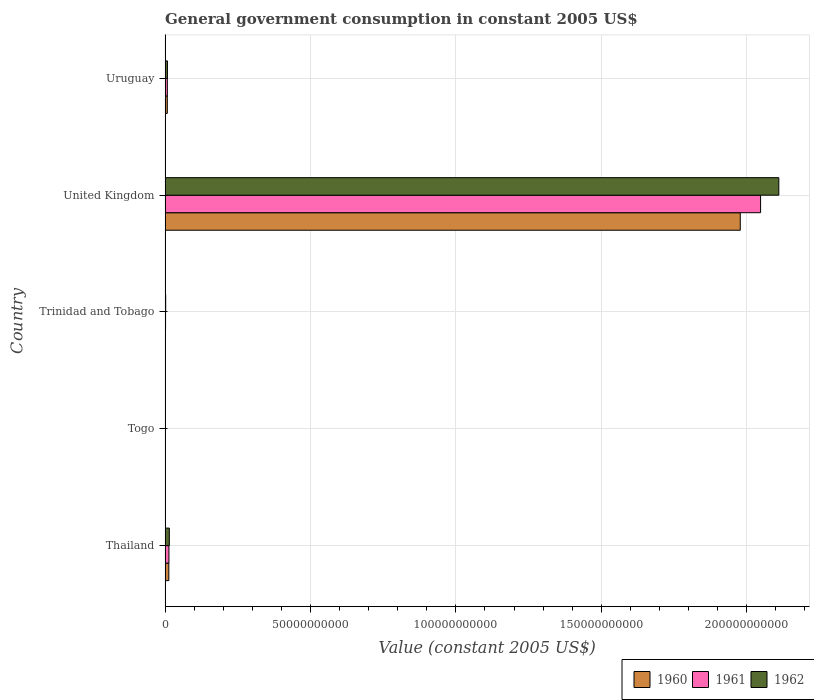How many different coloured bars are there?
Provide a short and direct response. 3. Are the number of bars per tick equal to the number of legend labels?
Give a very brief answer. Yes. Are the number of bars on each tick of the Y-axis equal?
Offer a terse response. Yes. How many bars are there on the 5th tick from the top?
Offer a very short reply. 3. What is the label of the 4th group of bars from the top?
Offer a terse response. Togo. What is the government conusmption in 1962 in Thailand?
Provide a succinct answer. 1.46e+09. Across all countries, what is the maximum government conusmption in 1962?
Your answer should be compact. 2.11e+11. Across all countries, what is the minimum government conusmption in 1961?
Your response must be concise. 4.33e+07. In which country was the government conusmption in 1962 minimum?
Your answer should be compact. Togo. What is the total government conusmption in 1960 in the graph?
Your answer should be very brief. 2.00e+11. What is the difference between the government conusmption in 1960 in Togo and that in Trinidad and Tobago?
Offer a very short reply. -5.67e+07. What is the difference between the government conusmption in 1960 in Togo and the government conusmption in 1961 in Uruguay?
Offer a terse response. -7.26e+08. What is the average government conusmption in 1961 per country?
Your answer should be compact. 4.14e+1. What is the difference between the government conusmption in 1962 and government conusmption in 1961 in United Kingdom?
Your response must be concise. 6.27e+09. What is the ratio of the government conusmption in 1960 in Trinidad and Tobago to that in Uruguay?
Your response must be concise. 0.14. What is the difference between the highest and the second highest government conusmption in 1960?
Give a very brief answer. 1.97e+11. What is the difference between the highest and the lowest government conusmption in 1962?
Offer a terse response. 2.11e+11. What does the 2nd bar from the top in Togo represents?
Offer a very short reply. 1961. What does the 2nd bar from the bottom in Thailand represents?
Provide a short and direct response. 1961. What is the difference between two consecutive major ticks on the X-axis?
Keep it short and to the point. 5.00e+1. Does the graph contain any zero values?
Provide a short and direct response. No. How many legend labels are there?
Make the answer very short. 3. What is the title of the graph?
Provide a succinct answer. General government consumption in constant 2005 US$. What is the label or title of the X-axis?
Your response must be concise. Value (constant 2005 US$). What is the label or title of the Y-axis?
Keep it short and to the point. Country. What is the Value (constant 2005 US$) of 1960 in Thailand?
Your response must be concise. 1.28e+09. What is the Value (constant 2005 US$) of 1961 in Thailand?
Provide a short and direct response. 1.32e+09. What is the Value (constant 2005 US$) of 1962 in Thailand?
Offer a terse response. 1.46e+09. What is the Value (constant 2005 US$) of 1960 in Togo?
Keep it short and to the point. 4.78e+07. What is the Value (constant 2005 US$) of 1961 in Togo?
Your answer should be very brief. 4.33e+07. What is the Value (constant 2005 US$) in 1962 in Togo?
Ensure brevity in your answer.  4.18e+07. What is the Value (constant 2005 US$) in 1960 in Trinidad and Tobago?
Your answer should be compact. 1.05e+08. What is the Value (constant 2005 US$) in 1961 in Trinidad and Tobago?
Your answer should be compact. 1.59e+08. What is the Value (constant 2005 US$) in 1962 in Trinidad and Tobago?
Provide a succinct answer. 2.04e+08. What is the Value (constant 2005 US$) of 1960 in United Kingdom?
Offer a very short reply. 1.98e+11. What is the Value (constant 2005 US$) of 1961 in United Kingdom?
Your answer should be very brief. 2.05e+11. What is the Value (constant 2005 US$) of 1962 in United Kingdom?
Give a very brief answer. 2.11e+11. What is the Value (constant 2005 US$) of 1960 in Uruguay?
Provide a succinct answer. 7.59e+08. What is the Value (constant 2005 US$) of 1961 in Uruguay?
Make the answer very short. 7.74e+08. What is the Value (constant 2005 US$) in 1962 in Uruguay?
Provide a short and direct response. 8.10e+08. Across all countries, what is the maximum Value (constant 2005 US$) of 1960?
Ensure brevity in your answer.  1.98e+11. Across all countries, what is the maximum Value (constant 2005 US$) in 1961?
Your response must be concise. 2.05e+11. Across all countries, what is the maximum Value (constant 2005 US$) in 1962?
Provide a succinct answer. 2.11e+11. Across all countries, what is the minimum Value (constant 2005 US$) of 1960?
Make the answer very short. 4.78e+07. Across all countries, what is the minimum Value (constant 2005 US$) in 1961?
Give a very brief answer. 4.33e+07. Across all countries, what is the minimum Value (constant 2005 US$) in 1962?
Keep it short and to the point. 4.18e+07. What is the total Value (constant 2005 US$) of 1960 in the graph?
Offer a very short reply. 2.00e+11. What is the total Value (constant 2005 US$) of 1961 in the graph?
Your answer should be compact. 2.07e+11. What is the total Value (constant 2005 US$) of 1962 in the graph?
Offer a terse response. 2.14e+11. What is the difference between the Value (constant 2005 US$) of 1960 in Thailand and that in Togo?
Provide a succinct answer. 1.23e+09. What is the difference between the Value (constant 2005 US$) of 1961 in Thailand and that in Togo?
Offer a terse response. 1.28e+09. What is the difference between the Value (constant 2005 US$) of 1962 in Thailand and that in Togo?
Keep it short and to the point. 1.41e+09. What is the difference between the Value (constant 2005 US$) in 1960 in Thailand and that in Trinidad and Tobago?
Offer a very short reply. 1.18e+09. What is the difference between the Value (constant 2005 US$) of 1961 in Thailand and that in Trinidad and Tobago?
Keep it short and to the point. 1.16e+09. What is the difference between the Value (constant 2005 US$) of 1962 in Thailand and that in Trinidad and Tobago?
Offer a very short reply. 1.25e+09. What is the difference between the Value (constant 2005 US$) of 1960 in Thailand and that in United Kingdom?
Give a very brief answer. -1.97e+11. What is the difference between the Value (constant 2005 US$) of 1961 in Thailand and that in United Kingdom?
Offer a very short reply. -2.03e+11. What is the difference between the Value (constant 2005 US$) of 1962 in Thailand and that in United Kingdom?
Provide a short and direct response. -2.10e+11. What is the difference between the Value (constant 2005 US$) of 1960 in Thailand and that in Uruguay?
Your answer should be very brief. 5.21e+08. What is the difference between the Value (constant 2005 US$) of 1961 in Thailand and that in Uruguay?
Your response must be concise. 5.46e+08. What is the difference between the Value (constant 2005 US$) of 1962 in Thailand and that in Uruguay?
Keep it short and to the point. 6.45e+08. What is the difference between the Value (constant 2005 US$) of 1960 in Togo and that in Trinidad and Tobago?
Keep it short and to the point. -5.67e+07. What is the difference between the Value (constant 2005 US$) in 1961 in Togo and that in Trinidad and Tobago?
Give a very brief answer. -1.16e+08. What is the difference between the Value (constant 2005 US$) in 1962 in Togo and that in Trinidad and Tobago?
Provide a short and direct response. -1.62e+08. What is the difference between the Value (constant 2005 US$) in 1960 in Togo and that in United Kingdom?
Your answer should be very brief. -1.98e+11. What is the difference between the Value (constant 2005 US$) in 1961 in Togo and that in United Kingdom?
Keep it short and to the point. -2.05e+11. What is the difference between the Value (constant 2005 US$) of 1962 in Togo and that in United Kingdom?
Give a very brief answer. -2.11e+11. What is the difference between the Value (constant 2005 US$) of 1960 in Togo and that in Uruguay?
Provide a succinct answer. -7.12e+08. What is the difference between the Value (constant 2005 US$) in 1961 in Togo and that in Uruguay?
Provide a succinct answer. -7.30e+08. What is the difference between the Value (constant 2005 US$) in 1962 in Togo and that in Uruguay?
Offer a terse response. -7.68e+08. What is the difference between the Value (constant 2005 US$) of 1960 in Trinidad and Tobago and that in United Kingdom?
Give a very brief answer. -1.98e+11. What is the difference between the Value (constant 2005 US$) in 1961 in Trinidad and Tobago and that in United Kingdom?
Make the answer very short. -2.05e+11. What is the difference between the Value (constant 2005 US$) of 1962 in Trinidad and Tobago and that in United Kingdom?
Offer a very short reply. -2.11e+11. What is the difference between the Value (constant 2005 US$) in 1960 in Trinidad and Tobago and that in Uruguay?
Your answer should be compact. -6.55e+08. What is the difference between the Value (constant 2005 US$) of 1961 in Trinidad and Tobago and that in Uruguay?
Keep it short and to the point. -6.14e+08. What is the difference between the Value (constant 2005 US$) in 1962 in Trinidad and Tobago and that in Uruguay?
Ensure brevity in your answer.  -6.06e+08. What is the difference between the Value (constant 2005 US$) of 1960 in United Kingdom and that in Uruguay?
Your answer should be compact. 1.97e+11. What is the difference between the Value (constant 2005 US$) of 1961 in United Kingdom and that in Uruguay?
Your answer should be very brief. 2.04e+11. What is the difference between the Value (constant 2005 US$) in 1962 in United Kingdom and that in Uruguay?
Keep it short and to the point. 2.10e+11. What is the difference between the Value (constant 2005 US$) in 1960 in Thailand and the Value (constant 2005 US$) in 1961 in Togo?
Ensure brevity in your answer.  1.24e+09. What is the difference between the Value (constant 2005 US$) of 1960 in Thailand and the Value (constant 2005 US$) of 1962 in Togo?
Your response must be concise. 1.24e+09. What is the difference between the Value (constant 2005 US$) in 1961 in Thailand and the Value (constant 2005 US$) in 1962 in Togo?
Give a very brief answer. 1.28e+09. What is the difference between the Value (constant 2005 US$) of 1960 in Thailand and the Value (constant 2005 US$) of 1961 in Trinidad and Tobago?
Give a very brief answer. 1.12e+09. What is the difference between the Value (constant 2005 US$) in 1960 in Thailand and the Value (constant 2005 US$) in 1962 in Trinidad and Tobago?
Your answer should be very brief. 1.08e+09. What is the difference between the Value (constant 2005 US$) of 1961 in Thailand and the Value (constant 2005 US$) of 1962 in Trinidad and Tobago?
Ensure brevity in your answer.  1.12e+09. What is the difference between the Value (constant 2005 US$) of 1960 in Thailand and the Value (constant 2005 US$) of 1961 in United Kingdom?
Keep it short and to the point. -2.04e+11. What is the difference between the Value (constant 2005 US$) in 1960 in Thailand and the Value (constant 2005 US$) in 1962 in United Kingdom?
Keep it short and to the point. -2.10e+11. What is the difference between the Value (constant 2005 US$) in 1961 in Thailand and the Value (constant 2005 US$) in 1962 in United Kingdom?
Ensure brevity in your answer.  -2.10e+11. What is the difference between the Value (constant 2005 US$) of 1960 in Thailand and the Value (constant 2005 US$) of 1961 in Uruguay?
Give a very brief answer. 5.07e+08. What is the difference between the Value (constant 2005 US$) in 1960 in Thailand and the Value (constant 2005 US$) in 1962 in Uruguay?
Give a very brief answer. 4.71e+08. What is the difference between the Value (constant 2005 US$) of 1961 in Thailand and the Value (constant 2005 US$) of 1962 in Uruguay?
Your answer should be very brief. 5.10e+08. What is the difference between the Value (constant 2005 US$) in 1960 in Togo and the Value (constant 2005 US$) in 1961 in Trinidad and Tobago?
Provide a short and direct response. -1.12e+08. What is the difference between the Value (constant 2005 US$) of 1960 in Togo and the Value (constant 2005 US$) of 1962 in Trinidad and Tobago?
Offer a terse response. -1.56e+08. What is the difference between the Value (constant 2005 US$) in 1961 in Togo and the Value (constant 2005 US$) in 1962 in Trinidad and Tobago?
Provide a short and direct response. -1.61e+08. What is the difference between the Value (constant 2005 US$) in 1960 in Togo and the Value (constant 2005 US$) in 1961 in United Kingdom?
Provide a succinct answer. -2.05e+11. What is the difference between the Value (constant 2005 US$) of 1960 in Togo and the Value (constant 2005 US$) of 1962 in United Kingdom?
Provide a succinct answer. -2.11e+11. What is the difference between the Value (constant 2005 US$) in 1961 in Togo and the Value (constant 2005 US$) in 1962 in United Kingdom?
Give a very brief answer. -2.11e+11. What is the difference between the Value (constant 2005 US$) in 1960 in Togo and the Value (constant 2005 US$) in 1961 in Uruguay?
Offer a very short reply. -7.26e+08. What is the difference between the Value (constant 2005 US$) of 1960 in Togo and the Value (constant 2005 US$) of 1962 in Uruguay?
Provide a short and direct response. -7.62e+08. What is the difference between the Value (constant 2005 US$) of 1961 in Togo and the Value (constant 2005 US$) of 1962 in Uruguay?
Your answer should be compact. -7.67e+08. What is the difference between the Value (constant 2005 US$) of 1960 in Trinidad and Tobago and the Value (constant 2005 US$) of 1961 in United Kingdom?
Give a very brief answer. -2.05e+11. What is the difference between the Value (constant 2005 US$) of 1960 in Trinidad and Tobago and the Value (constant 2005 US$) of 1962 in United Kingdom?
Ensure brevity in your answer.  -2.11e+11. What is the difference between the Value (constant 2005 US$) of 1961 in Trinidad and Tobago and the Value (constant 2005 US$) of 1962 in United Kingdom?
Offer a very short reply. -2.11e+11. What is the difference between the Value (constant 2005 US$) of 1960 in Trinidad and Tobago and the Value (constant 2005 US$) of 1961 in Uruguay?
Your answer should be compact. -6.69e+08. What is the difference between the Value (constant 2005 US$) in 1960 in Trinidad and Tobago and the Value (constant 2005 US$) in 1962 in Uruguay?
Provide a succinct answer. -7.05e+08. What is the difference between the Value (constant 2005 US$) in 1961 in Trinidad and Tobago and the Value (constant 2005 US$) in 1962 in Uruguay?
Your answer should be very brief. -6.51e+08. What is the difference between the Value (constant 2005 US$) of 1960 in United Kingdom and the Value (constant 2005 US$) of 1961 in Uruguay?
Your response must be concise. 1.97e+11. What is the difference between the Value (constant 2005 US$) in 1960 in United Kingdom and the Value (constant 2005 US$) in 1962 in Uruguay?
Ensure brevity in your answer.  1.97e+11. What is the difference between the Value (constant 2005 US$) of 1961 in United Kingdom and the Value (constant 2005 US$) of 1962 in Uruguay?
Provide a short and direct response. 2.04e+11. What is the average Value (constant 2005 US$) of 1960 per country?
Give a very brief answer. 4.00e+1. What is the average Value (constant 2005 US$) of 1961 per country?
Provide a succinct answer. 4.14e+1. What is the average Value (constant 2005 US$) of 1962 per country?
Your response must be concise. 4.27e+1. What is the difference between the Value (constant 2005 US$) of 1960 and Value (constant 2005 US$) of 1961 in Thailand?
Offer a terse response. -3.88e+07. What is the difference between the Value (constant 2005 US$) in 1960 and Value (constant 2005 US$) in 1962 in Thailand?
Your response must be concise. -1.75e+08. What is the difference between the Value (constant 2005 US$) in 1961 and Value (constant 2005 US$) in 1962 in Thailand?
Offer a very short reply. -1.36e+08. What is the difference between the Value (constant 2005 US$) of 1960 and Value (constant 2005 US$) of 1961 in Togo?
Your answer should be compact. 4.55e+06. What is the difference between the Value (constant 2005 US$) of 1960 and Value (constant 2005 US$) of 1962 in Togo?
Provide a short and direct response. 6.07e+06. What is the difference between the Value (constant 2005 US$) in 1961 and Value (constant 2005 US$) in 1962 in Togo?
Keep it short and to the point. 1.52e+06. What is the difference between the Value (constant 2005 US$) of 1960 and Value (constant 2005 US$) of 1961 in Trinidad and Tobago?
Provide a short and direct response. -5.49e+07. What is the difference between the Value (constant 2005 US$) of 1960 and Value (constant 2005 US$) of 1962 in Trinidad and Tobago?
Your answer should be compact. -9.94e+07. What is the difference between the Value (constant 2005 US$) of 1961 and Value (constant 2005 US$) of 1962 in Trinidad and Tobago?
Ensure brevity in your answer.  -4.45e+07. What is the difference between the Value (constant 2005 US$) of 1960 and Value (constant 2005 US$) of 1961 in United Kingdom?
Provide a short and direct response. -6.98e+09. What is the difference between the Value (constant 2005 US$) in 1960 and Value (constant 2005 US$) in 1962 in United Kingdom?
Your answer should be compact. -1.33e+1. What is the difference between the Value (constant 2005 US$) of 1961 and Value (constant 2005 US$) of 1962 in United Kingdom?
Offer a very short reply. -6.27e+09. What is the difference between the Value (constant 2005 US$) of 1960 and Value (constant 2005 US$) of 1961 in Uruguay?
Your answer should be very brief. -1.43e+07. What is the difference between the Value (constant 2005 US$) in 1960 and Value (constant 2005 US$) in 1962 in Uruguay?
Provide a succinct answer. -5.05e+07. What is the difference between the Value (constant 2005 US$) in 1961 and Value (constant 2005 US$) in 1962 in Uruguay?
Your answer should be very brief. -3.62e+07. What is the ratio of the Value (constant 2005 US$) of 1960 in Thailand to that in Togo?
Make the answer very short. 26.78. What is the ratio of the Value (constant 2005 US$) in 1961 in Thailand to that in Togo?
Ensure brevity in your answer.  30.49. What is the ratio of the Value (constant 2005 US$) of 1962 in Thailand to that in Togo?
Provide a succinct answer. 34.86. What is the ratio of the Value (constant 2005 US$) in 1960 in Thailand to that in Trinidad and Tobago?
Offer a terse response. 12.25. What is the ratio of the Value (constant 2005 US$) of 1961 in Thailand to that in Trinidad and Tobago?
Ensure brevity in your answer.  8.28. What is the ratio of the Value (constant 2005 US$) in 1962 in Thailand to that in Trinidad and Tobago?
Your answer should be very brief. 7.14. What is the ratio of the Value (constant 2005 US$) in 1960 in Thailand to that in United Kingdom?
Your answer should be compact. 0.01. What is the ratio of the Value (constant 2005 US$) of 1961 in Thailand to that in United Kingdom?
Provide a short and direct response. 0.01. What is the ratio of the Value (constant 2005 US$) of 1962 in Thailand to that in United Kingdom?
Your response must be concise. 0.01. What is the ratio of the Value (constant 2005 US$) of 1960 in Thailand to that in Uruguay?
Provide a short and direct response. 1.69. What is the ratio of the Value (constant 2005 US$) of 1961 in Thailand to that in Uruguay?
Provide a short and direct response. 1.71. What is the ratio of the Value (constant 2005 US$) in 1962 in Thailand to that in Uruguay?
Keep it short and to the point. 1.8. What is the ratio of the Value (constant 2005 US$) of 1960 in Togo to that in Trinidad and Tobago?
Provide a succinct answer. 0.46. What is the ratio of the Value (constant 2005 US$) of 1961 in Togo to that in Trinidad and Tobago?
Ensure brevity in your answer.  0.27. What is the ratio of the Value (constant 2005 US$) in 1962 in Togo to that in Trinidad and Tobago?
Provide a succinct answer. 0.2. What is the ratio of the Value (constant 2005 US$) in 1960 in Togo to that in United Kingdom?
Provide a succinct answer. 0. What is the ratio of the Value (constant 2005 US$) of 1962 in Togo to that in United Kingdom?
Keep it short and to the point. 0. What is the ratio of the Value (constant 2005 US$) in 1960 in Togo to that in Uruguay?
Keep it short and to the point. 0.06. What is the ratio of the Value (constant 2005 US$) of 1961 in Togo to that in Uruguay?
Provide a succinct answer. 0.06. What is the ratio of the Value (constant 2005 US$) in 1962 in Togo to that in Uruguay?
Keep it short and to the point. 0.05. What is the ratio of the Value (constant 2005 US$) in 1960 in Trinidad and Tobago to that in United Kingdom?
Offer a terse response. 0. What is the ratio of the Value (constant 2005 US$) in 1961 in Trinidad and Tobago to that in United Kingdom?
Ensure brevity in your answer.  0. What is the ratio of the Value (constant 2005 US$) in 1960 in Trinidad and Tobago to that in Uruguay?
Make the answer very short. 0.14. What is the ratio of the Value (constant 2005 US$) of 1961 in Trinidad and Tobago to that in Uruguay?
Provide a succinct answer. 0.21. What is the ratio of the Value (constant 2005 US$) in 1962 in Trinidad and Tobago to that in Uruguay?
Make the answer very short. 0.25. What is the ratio of the Value (constant 2005 US$) in 1960 in United Kingdom to that in Uruguay?
Offer a terse response. 260.47. What is the ratio of the Value (constant 2005 US$) of 1961 in United Kingdom to that in Uruguay?
Make the answer very short. 264.67. What is the ratio of the Value (constant 2005 US$) in 1962 in United Kingdom to that in Uruguay?
Your answer should be very brief. 260.59. What is the difference between the highest and the second highest Value (constant 2005 US$) of 1960?
Provide a short and direct response. 1.97e+11. What is the difference between the highest and the second highest Value (constant 2005 US$) in 1961?
Keep it short and to the point. 2.03e+11. What is the difference between the highest and the second highest Value (constant 2005 US$) in 1962?
Offer a terse response. 2.10e+11. What is the difference between the highest and the lowest Value (constant 2005 US$) of 1960?
Offer a terse response. 1.98e+11. What is the difference between the highest and the lowest Value (constant 2005 US$) of 1961?
Provide a short and direct response. 2.05e+11. What is the difference between the highest and the lowest Value (constant 2005 US$) of 1962?
Offer a terse response. 2.11e+11. 